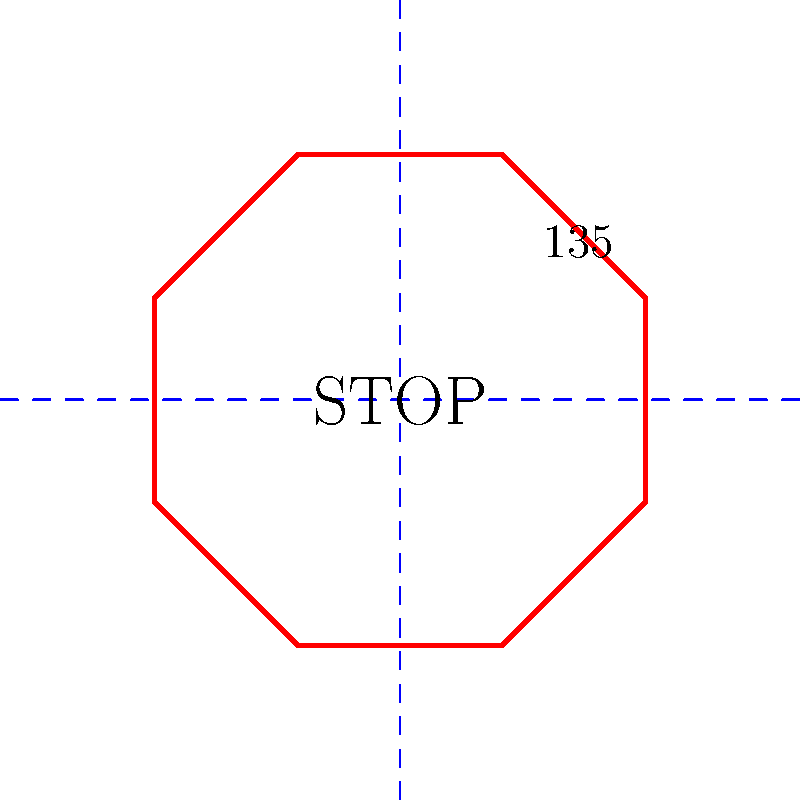On your way to the community center, you notice a STOP sign. What is the measure of the angle between any two adjacent sides of this octagonal sign? Let's approach this step-by-step:

1) A STOP sign is in the shape of a regular octagon.

2) A regular octagon has 8 sides and 8 angles.

3) In any polygon, the sum of all interior angles is given by the formula:
   $$(n-2) \times 180°$$
   where $n$ is the number of sides.

4) For an octagon, $n = 8$, so the sum of all interior angles is:
   $$(8-2) \times 180° = 6 \times 180° = 1080°$$

5) Since a regular octagon has all equal angles, we can find each interior angle by dividing the sum by 8:
   $$1080° \div 8 = 135°$$

6) Therefore, the angle between any two adjacent sides of a regular octagon (like a STOP sign) is 135°.

This knowledge can help you explain to your children why STOP signs have this particular shape, making your trips to the community center more educational!
Answer: 135° 